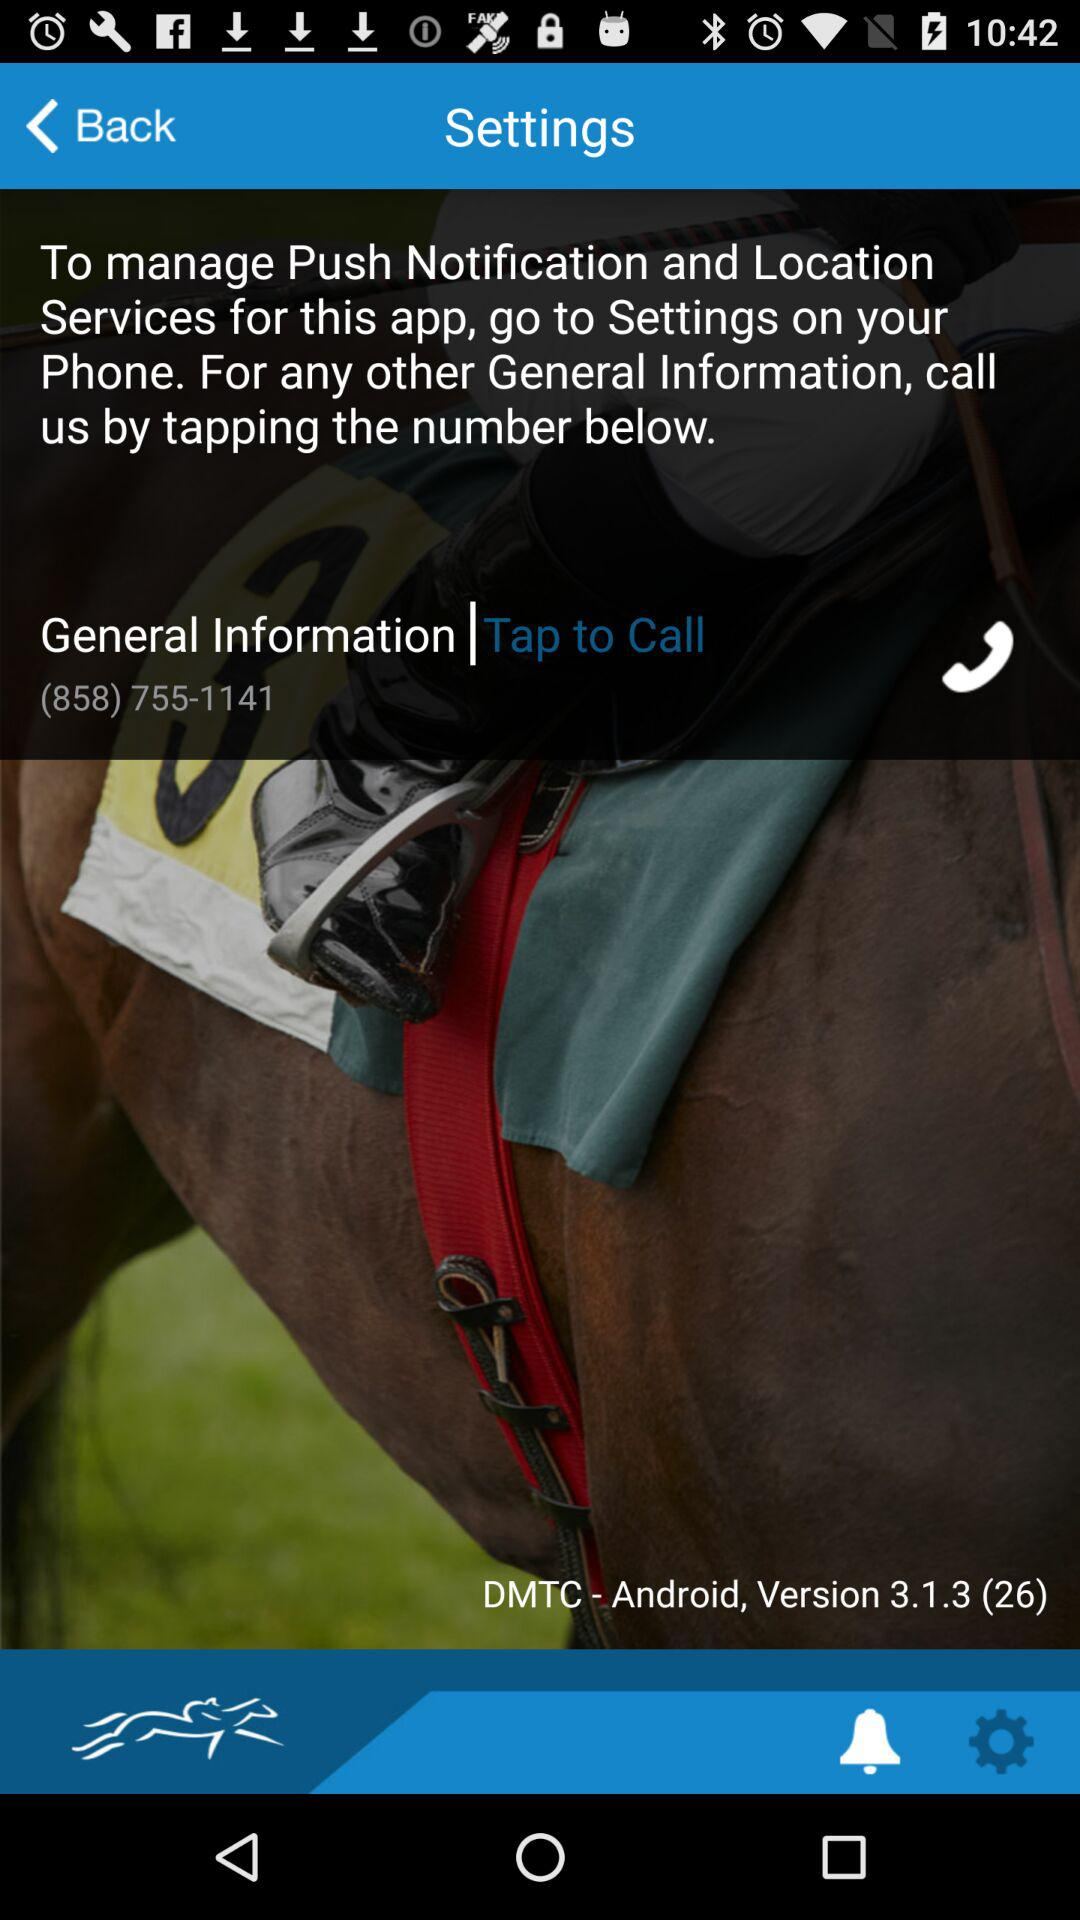What is the version of the application? The version of the application is 3.1.3 (26). 